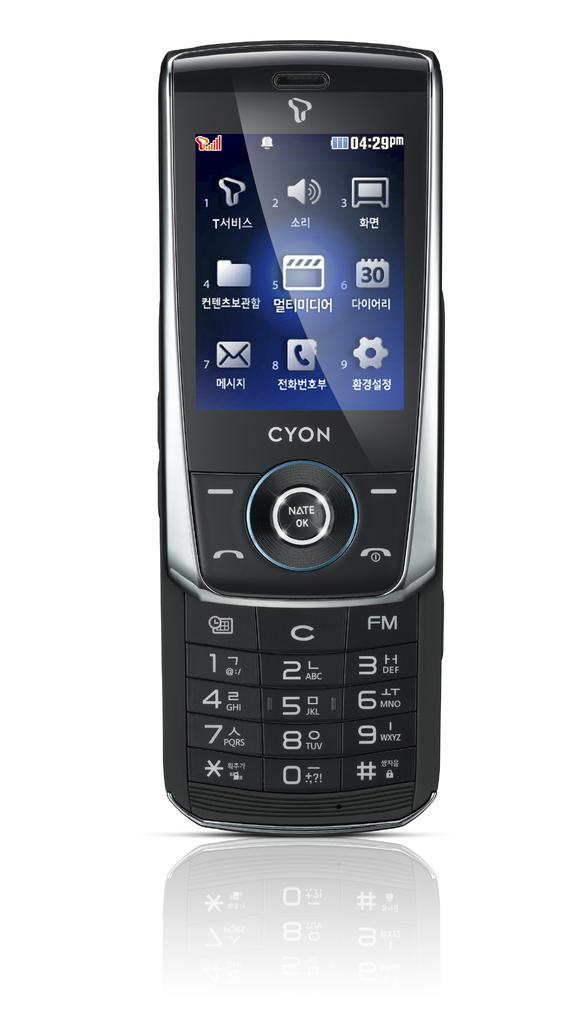<image>
Write a terse but informative summary of the picture. CYON smartphone that has many apps and it says 4:29 PM on the top. 